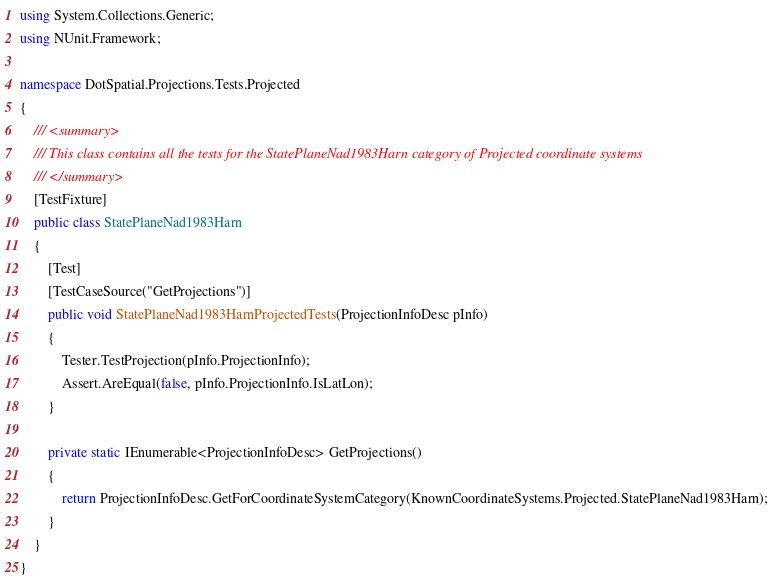Convert code to text. <code><loc_0><loc_0><loc_500><loc_500><_C#_>using System.Collections.Generic;
using NUnit.Framework;

namespace DotSpatial.Projections.Tests.Projected
{
    /// <summary>
    /// This class contains all the tests for the StatePlaneNad1983Harn category of Projected coordinate systems
    /// </summary>
    [TestFixture]
    public class StatePlaneNad1983Harn
    {
        [Test]
        [TestCaseSource("GetProjections")]
        public void StatePlaneNad1983HarnProjectedTests(ProjectionInfoDesc pInfo)
        {
            Tester.TestProjection(pInfo.ProjectionInfo);
            Assert.AreEqual(false, pInfo.ProjectionInfo.IsLatLon);
        }

        private static IEnumerable<ProjectionInfoDesc> GetProjections()
        {
            return ProjectionInfoDesc.GetForCoordinateSystemCategory(KnownCoordinateSystems.Projected.StatePlaneNad1983Harn);
        }
    }
}</code> 